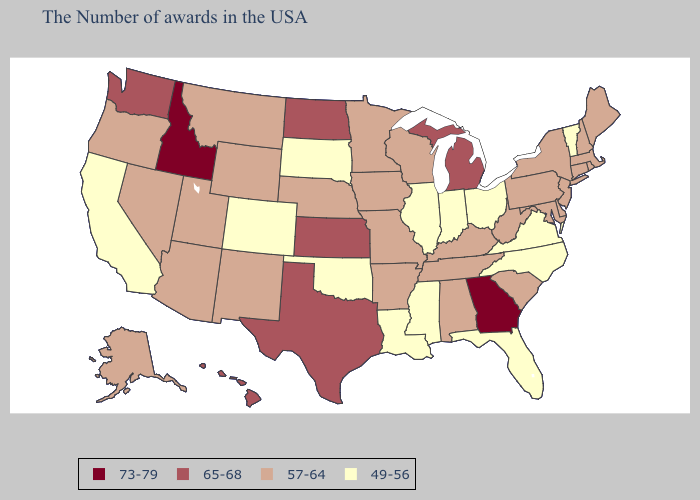Among the states that border Kansas , does Missouri have the lowest value?
Write a very short answer. No. Name the states that have a value in the range 57-64?
Give a very brief answer. Maine, Massachusetts, Rhode Island, New Hampshire, Connecticut, New York, New Jersey, Delaware, Maryland, Pennsylvania, South Carolina, West Virginia, Kentucky, Alabama, Tennessee, Wisconsin, Missouri, Arkansas, Minnesota, Iowa, Nebraska, Wyoming, New Mexico, Utah, Montana, Arizona, Nevada, Oregon, Alaska. Name the states that have a value in the range 73-79?
Be succinct. Georgia, Idaho. Name the states that have a value in the range 57-64?
Concise answer only. Maine, Massachusetts, Rhode Island, New Hampshire, Connecticut, New York, New Jersey, Delaware, Maryland, Pennsylvania, South Carolina, West Virginia, Kentucky, Alabama, Tennessee, Wisconsin, Missouri, Arkansas, Minnesota, Iowa, Nebraska, Wyoming, New Mexico, Utah, Montana, Arizona, Nevada, Oregon, Alaska. Which states hav the highest value in the MidWest?
Give a very brief answer. Michigan, Kansas, North Dakota. Name the states that have a value in the range 65-68?
Quick response, please. Michigan, Kansas, Texas, North Dakota, Washington, Hawaii. What is the lowest value in the Northeast?
Keep it brief. 49-56. Does Wisconsin have a higher value than Louisiana?
Answer briefly. Yes. Among the states that border Massachusetts , which have the highest value?
Be succinct. Rhode Island, New Hampshire, Connecticut, New York. Does Vermont have the highest value in the Northeast?
Give a very brief answer. No. How many symbols are there in the legend?
Give a very brief answer. 4. Among the states that border Oklahoma , which have the highest value?
Write a very short answer. Kansas, Texas. Among the states that border Massachusetts , which have the lowest value?
Be succinct. Vermont. Name the states that have a value in the range 49-56?
Keep it brief. Vermont, Virginia, North Carolina, Ohio, Florida, Indiana, Illinois, Mississippi, Louisiana, Oklahoma, South Dakota, Colorado, California. What is the highest value in states that border Illinois?
Write a very short answer. 57-64. 